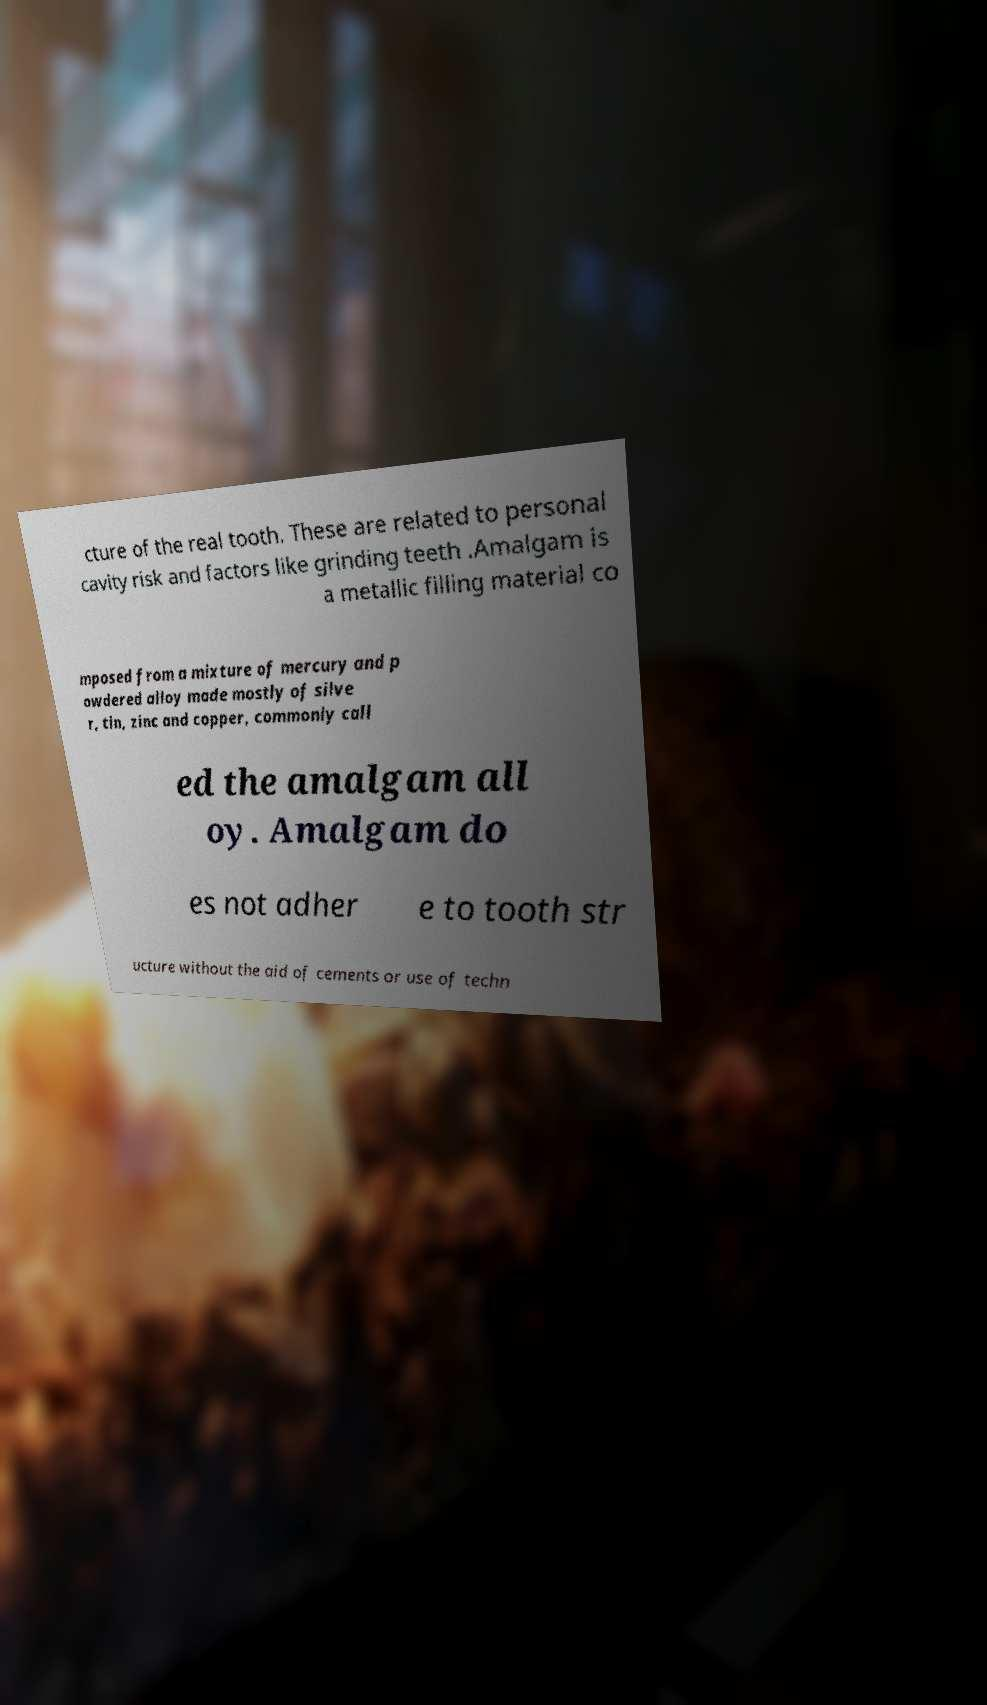Can you read and provide the text displayed in the image?This photo seems to have some interesting text. Can you extract and type it out for me? cture of the real tooth. These are related to personal cavity risk and factors like grinding teeth .Amalgam is a metallic filling material co mposed from a mixture of mercury and p owdered alloy made mostly of silve r, tin, zinc and copper, commonly call ed the amalgam all oy. Amalgam do es not adher e to tooth str ucture without the aid of cements or use of techn 